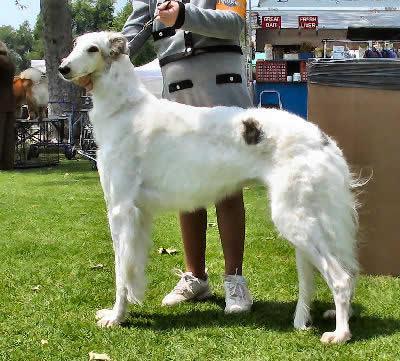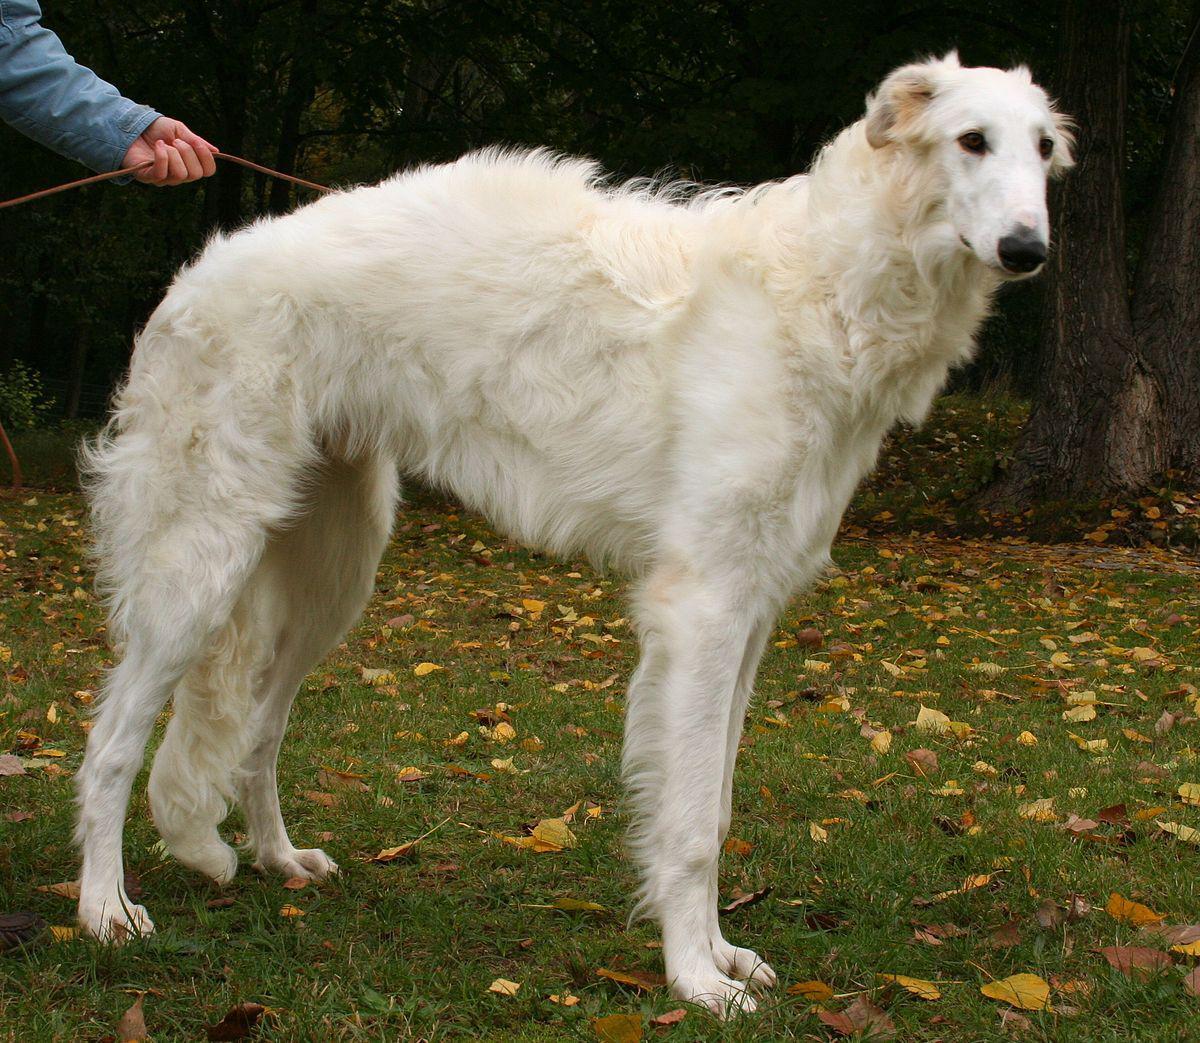The first image is the image on the left, the second image is the image on the right. For the images shown, is this caption "There are two dogs" true? Answer yes or no. Yes. The first image is the image on the left, the second image is the image on the right. Given the left and right images, does the statement "A single large dog is standing upright in each image." hold true? Answer yes or no. Yes. The first image is the image on the left, the second image is the image on the right. Given the left and right images, does the statement "All images show one hound standing in profile on grass." hold true? Answer yes or no. Yes. 